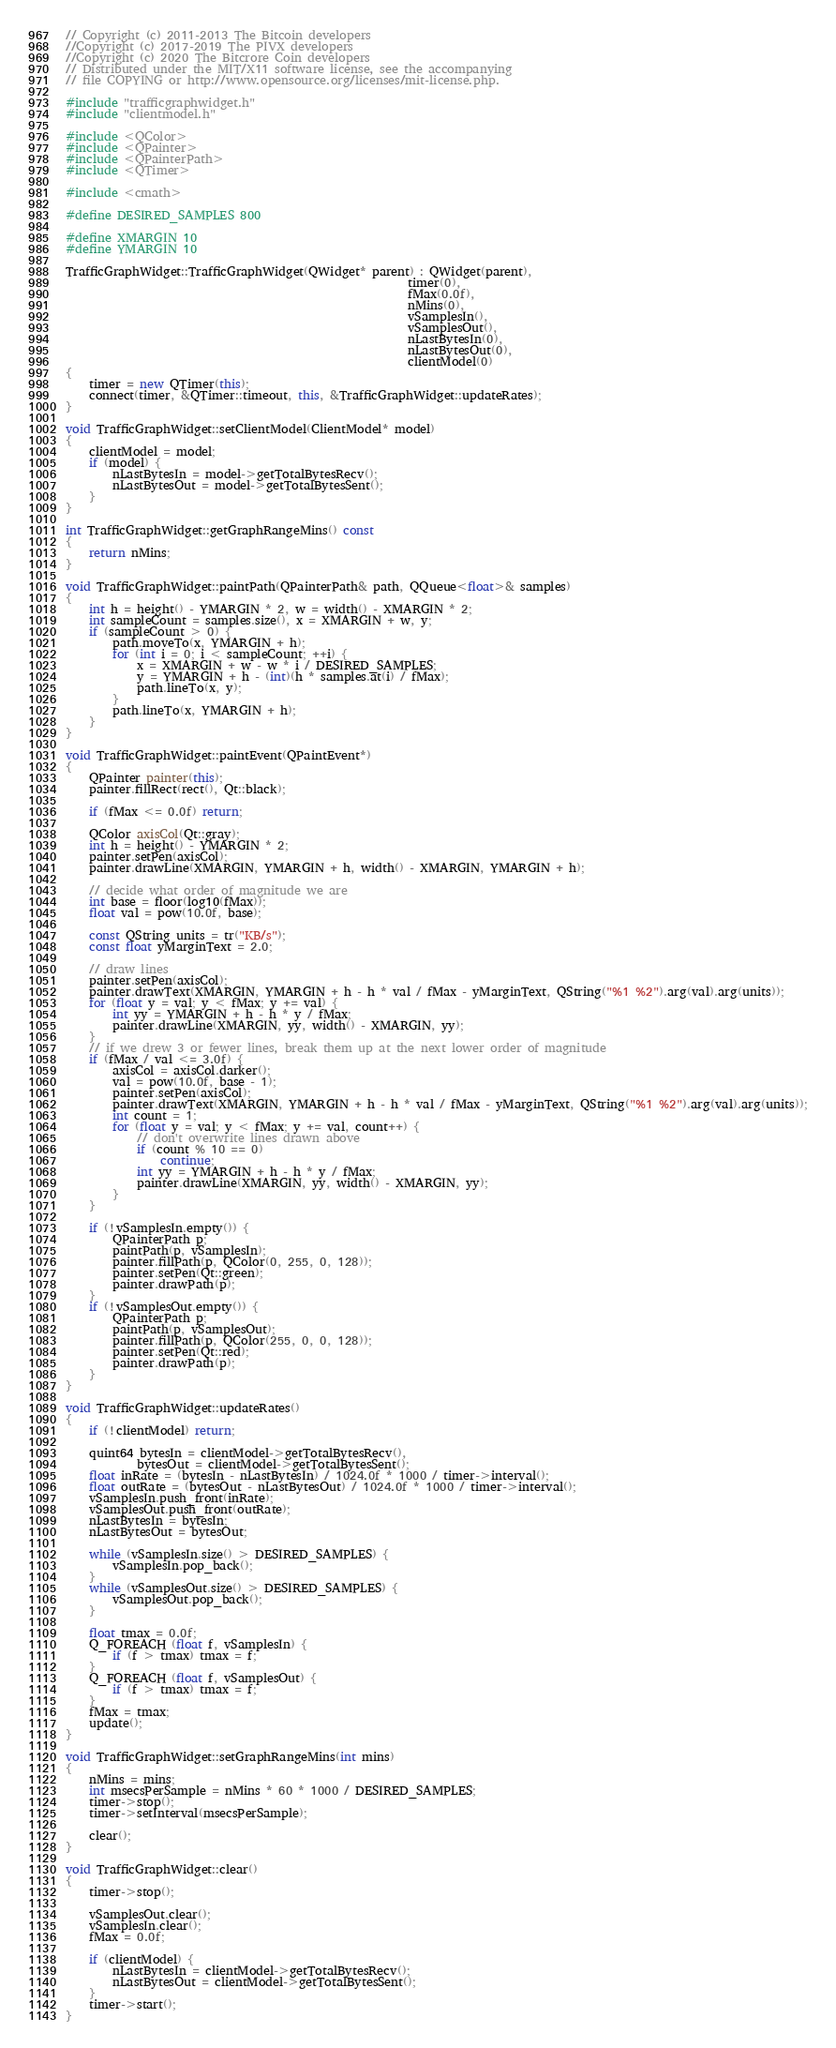Convert code to text. <code><loc_0><loc_0><loc_500><loc_500><_C++_>// Copyright (c) 2011-2013 The Bitcoin developers
//Copyright (c) 2017-2019 The PIVX developers
//Copyright (c) 2020 The Bitcrore Coin developers
// Distributed under the MIT/X11 software license, see the accompanying
// file COPYING or http://www.opensource.org/licenses/mit-license.php.

#include "trafficgraphwidget.h"
#include "clientmodel.h"

#include <QColor>
#include <QPainter>
#include <QPainterPath>
#include <QTimer>

#include <cmath>

#define DESIRED_SAMPLES 800

#define XMARGIN 10
#define YMARGIN 10

TrafficGraphWidget::TrafficGraphWidget(QWidget* parent) : QWidget(parent),
                                                          timer(0),
                                                          fMax(0.0f),
                                                          nMins(0),
                                                          vSamplesIn(),
                                                          vSamplesOut(),
                                                          nLastBytesIn(0),
                                                          nLastBytesOut(0),
                                                          clientModel(0)
{
    timer = new QTimer(this);
    connect(timer, &QTimer::timeout, this, &TrafficGraphWidget::updateRates);
}

void TrafficGraphWidget::setClientModel(ClientModel* model)
{
    clientModel = model;
    if (model) {
        nLastBytesIn = model->getTotalBytesRecv();
        nLastBytesOut = model->getTotalBytesSent();
    }
}

int TrafficGraphWidget::getGraphRangeMins() const
{
    return nMins;
}

void TrafficGraphWidget::paintPath(QPainterPath& path, QQueue<float>& samples)
{
    int h = height() - YMARGIN * 2, w = width() - XMARGIN * 2;
    int sampleCount = samples.size(), x = XMARGIN + w, y;
    if (sampleCount > 0) {
        path.moveTo(x, YMARGIN + h);
        for (int i = 0; i < sampleCount; ++i) {
            x = XMARGIN + w - w * i / DESIRED_SAMPLES;
            y = YMARGIN + h - (int)(h * samples.at(i) / fMax);
            path.lineTo(x, y);
        }
        path.lineTo(x, YMARGIN + h);
    }
}

void TrafficGraphWidget::paintEvent(QPaintEvent*)
{
    QPainter painter(this);
    painter.fillRect(rect(), Qt::black);

    if (fMax <= 0.0f) return;

    QColor axisCol(Qt::gray);
    int h = height() - YMARGIN * 2;
    painter.setPen(axisCol);
    painter.drawLine(XMARGIN, YMARGIN + h, width() - XMARGIN, YMARGIN + h);

    // decide what order of magnitude we are
    int base = floor(log10(fMax));
    float val = pow(10.0f, base);

    const QString units = tr("KB/s");
    const float yMarginText = 2.0;

    // draw lines
    painter.setPen(axisCol);
    painter.drawText(XMARGIN, YMARGIN + h - h * val / fMax - yMarginText, QString("%1 %2").arg(val).arg(units));
    for (float y = val; y < fMax; y += val) {
        int yy = YMARGIN + h - h * y / fMax;
        painter.drawLine(XMARGIN, yy, width() - XMARGIN, yy);
    }
    // if we drew 3 or fewer lines, break them up at the next lower order of magnitude
    if (fMax / val <= 3.0f) {
        axisCol = axisCol.darker();
        val = pow(10.0f, base - 1);
        painter.setPen(axisCol);
        painter.drawText(XMARGIN, YMARGIN + h - h * val / fMax - yMarginText, QString("%1 %2").arg(val).arg(units));
        int count = 1;
        for (float y = val; y < fMax; y += val, count++) {
            // don't overwrite lines drawn above
            if (count % 10 == 0)
                continue;
            int yy = YMARGIN + h - h * y / fMax;
            painter.drawLine(XMARGIN, yy, width() - XMARGIN, yy);
        }
    }

    if (!vSamplesIn.empty()) {
        QPainterPath p;
        paintPath(p, vSamplesIn);
        painter.fillPath(p, QColor(0, 255, 0, 128));
        painter.setPen(Qt::green);
        painter.drawPath(p);
    }
    if (!vSamplesOut.empty()) {
        QPainterPath p;
        paintPath(p, vSamplesOut);
        painter.fillPath(p, QColor(255, 0, 0, 128));
        painter.setPen(Qt::red);
        painter.drawPath(p);
    }
}

void TrafficGraphWidget::updateRates()
{
    if (!clientModel) return;

    quint64 bytesIn = clientModel->getTotalBytesRecv(),
            bytesOut = clientModel->getTotalBytesSent();
    float inRate = (bytesIn - nLastBytesIn) / 1024.0f * 1000 / timer->interval();
    float outRate = (bytesOut - nLastBytesOut) / 1024.0f * 1000 / timer->interval();
    vSamplesIn.push_front(inRate);
    vSamplesOut.push_front(outRate);
    nLastBytesIn = bytesIn;
    nLastBytesOut = bytesOut;

    while (vSamplesIn.size() > DESIRED_SAMPLES) {
        vSamplesIn.pop_back();
    }
    while (vSamplesOut.size() > DESIRED_SAMPLES) {
        vSamplesOut.pop_back();
    }

    float tmax = 0.0f;
    Q_FOREACH (float f, vSamplesIn) {
        if (f > tmax) tmax = f;
    }
    Q_FOREACH (float f, vSamplesOut) {
        if (f > tmax) tmax = f;
    }
    fMax = tmax;
    update();
}

void TrafficGraphWidget::setGraphRangeMins(int mins)
{
    nMins = mins;
    int msecsPerSample = nMins * 60 * 1000 / DESIRED_SAMPLES;
    timer->stop();
    timer->setInterval(msecsPerSample);

    clear();
}

void TrafficGraphWidget::clear()
{
    timer->stop();

    vSamplesOut.clear();
    vSamplesIn.clear();
    fMax = 0.0f;

    if (clientModel) {
        nLastBytesIn = clientModel->getTotalBytesRecv();
        nLastBytesOut = clientModel->getTotalBytesSent();
    }
    timer->start();
}
</code> 